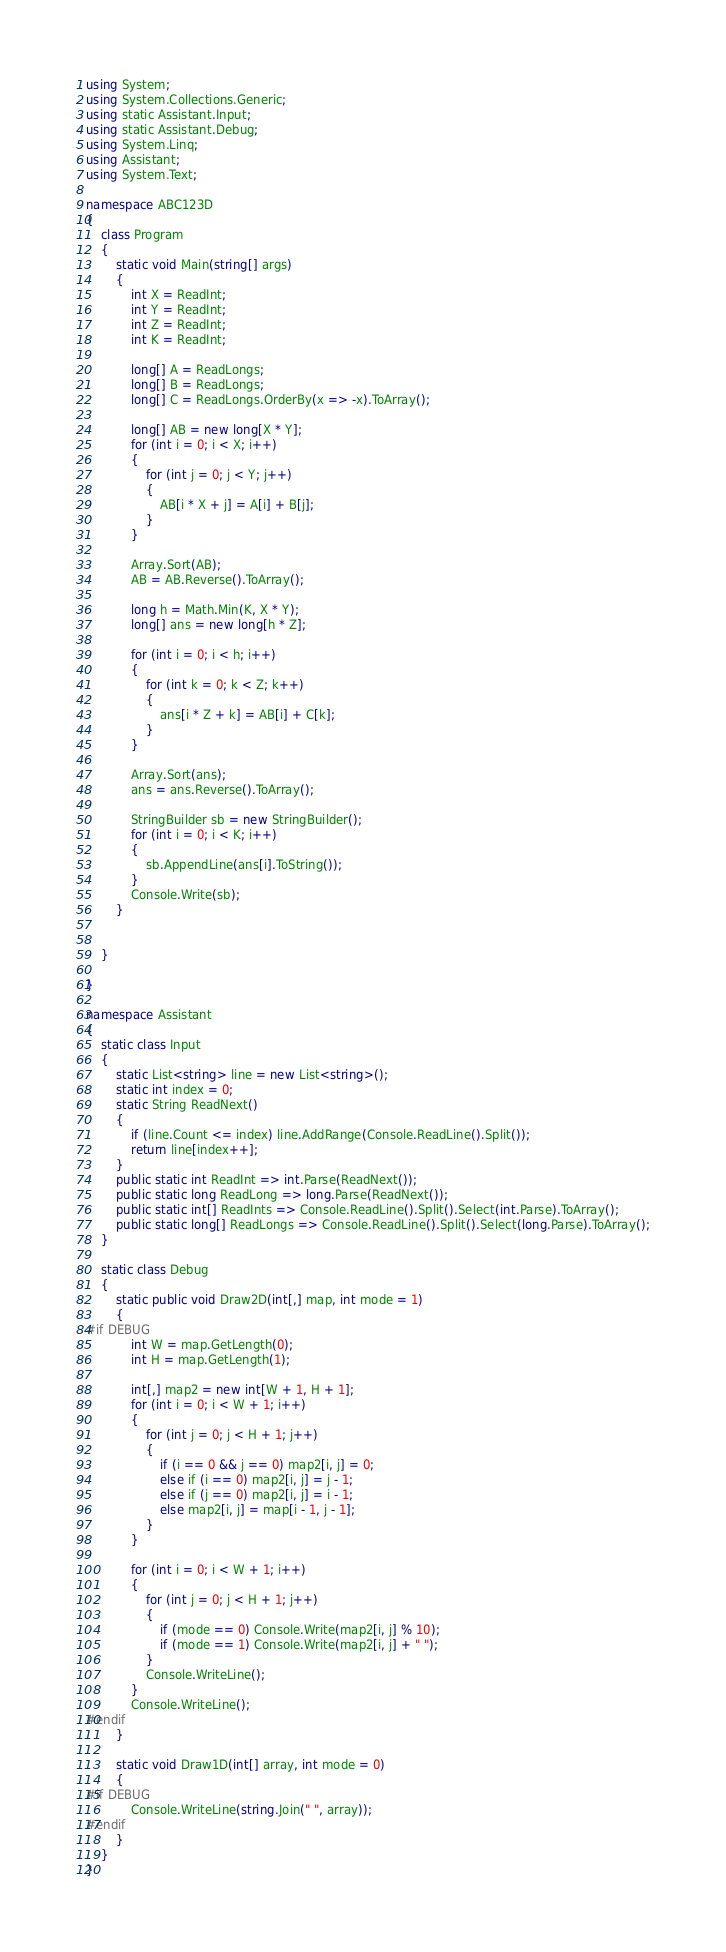<code> <loc_0><loc_0><loc_500><loc_500><_C#_>using System;
using System.Collections.Generic;
using static Assistant.Input;
using static Assistant.Debug;
using System.Linq;
using Assistant;
using System.Text;

namespace ABC123D
{
    class Program
    {
        static void Main(string[] args)
        {
            int X = ReadInt;
            int Y = ReadInt;
            int Z = ReadInt;
            int K = ReadInt;

            long[] A = ReadLongs;
            long[] B = ReadLongs;
            long[] C = ReadLongs.OrderBy(x => -x).ToArray();

            long[] AB = new long[X * Y];
            for (int i = 0; i < X; i++)
            {
                for (int j = 0; j < Y; j++)
                {
                    AB[i * X + j] = A[i] + B[j];
                }
            }

            Array.Sort(AB);
            AB = AB.Reverse().ToArray();

            long h = Math.Min(K, X * Y);
            long[] ans = new long[h * Z];

            for (int i = 0; i < h; i++)
            {
                for (int k = 0; k < Z; k++)
                {
                    ans[i * Z + k] = AB[i] + C[k];
                }
            }

            Array.Sort(ans);
            ans = ans.Reverse().ToArray();

            StringBuilder sb = new StringBuilder();
            for (int i = 0; i < K; i++)
            {
                sb.AppendLine(ans[i].ToString());
            }
            Console.Write(sb);
        }


    }

}

namespace Assistant
{
    static class Input
    {
        static List<string> line = new List<string>();
        static int index = 0;
        static String ReadNext()
        {
            if (line.Count <= index) line.AddRange(Console.ReadLine().Split());
            return line[index++];
        }
        public static int ReadInt => int.Parse(ReadNext());
        public static long ReadLong => long.Parse(ReadNext());
        public static int[] ReadInts => Console.ReadLine().Split().Select(int.Parse).ToArray();
        public static long[] ReadLongs => Console.ReadLine().Split().Select(long.Parse).ToArray();
    }

    static class Debug
    {
        static public void Draw2D(int[,] map, int mode = 1)
        {
#if DEBUG
            int W = map.GetLength(0);
            int H = map.GetLength(1);

            int[,] map2 = new int[W + 1, H + 1];
            for (int i = 0; i < W + 1; i++)
            {
                for (int j = 0; j < H + 1; j++)
                {
                    if (i == 0 && j == 0) map2[i, j] = 0;
                    else if (i == 0) map2[i, j] = j - 1;
                    else if (j == 0) map2[i, j] = i - 1;
                    else map2[i, j] = map[i - 1, j - 1];
                }
            }

            for (int i = 0; i < W + 1; i++)
            {
                for (int j = 0; j < H + 1; j++)
                {
                    if (mode == 0) Console.Write(map2[i, j] % 10);
                    if (mode == 1) Console.Write(map2[i, j] + " ");
                }
                Console.WriteLine();
            }
            Console.WriteLine();
#endif
        }

        static void Draw1D(int[] array, int mode = 0)
        {
#if DEBUG
            Console.WriteLine(string.Join(" ", array));
#endif
        }
    }
}
</code> 